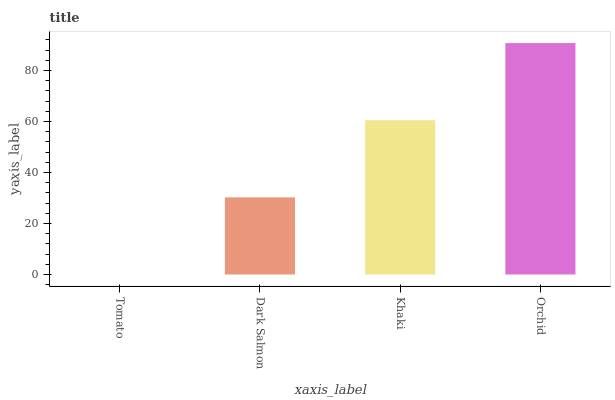Is Tomato the minimum?
Answer yes or no. Yes. Is Orchid the maximum?
Answer yes or no. Yes. Is Dark Salmon the minimum?
Answer yes or no. No. Is Dark Salmon the maximum?
Answer yes or no. No. Is Dark Salmon greater than Tomato?
Answer yes or no. Yes. Is Tomato less than Dark Salmon?
Answer yes or no. Yes. Is Tomato greater than Dark Salmon?
Answer yes or no. No. Is Dark Salmon less than Tomato?
Answer yes or no. No. Is Khaki the high median?
Answer yes or no. Yes. Is Dark Salmon the low median?
Answer yes or no. Yes. Is Dark Salmon the high median?
Answer yes or no. No. Is Khaki the low median?
Answer yes or no. No. 